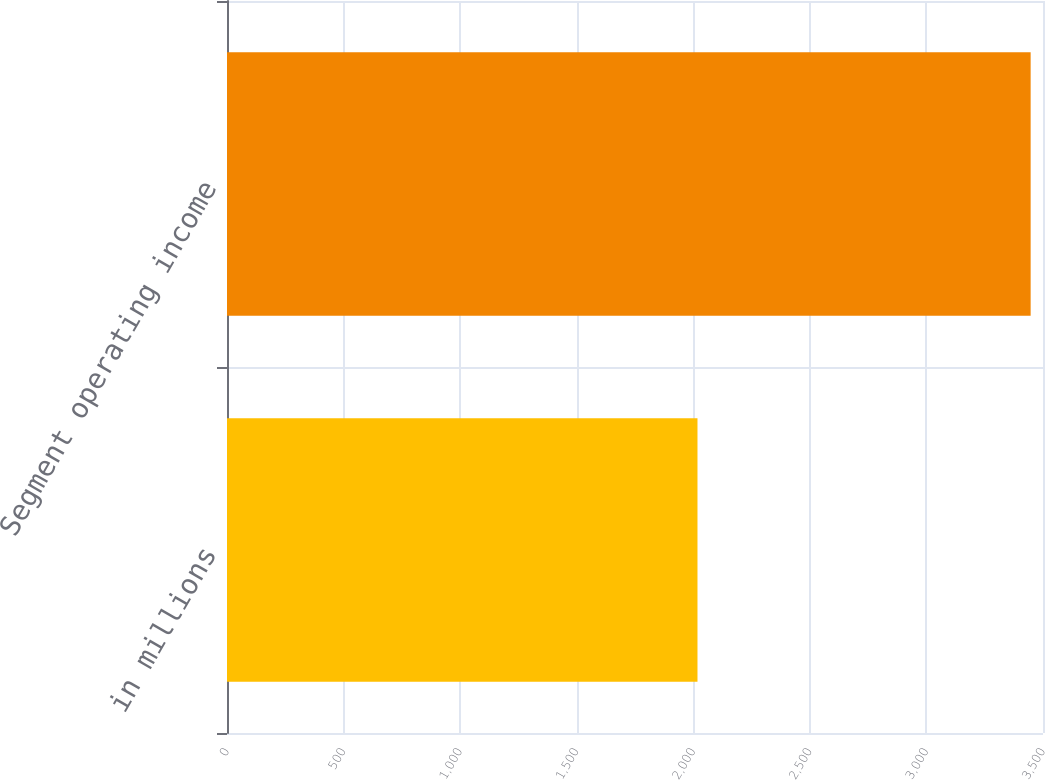<chart> <loc_0><loc_0><loc_500><loc_500><bar_chart><fcel>in millions<fcel>Segment operating income<nl><fcel>2018<fcel>3447<nl></chart> 